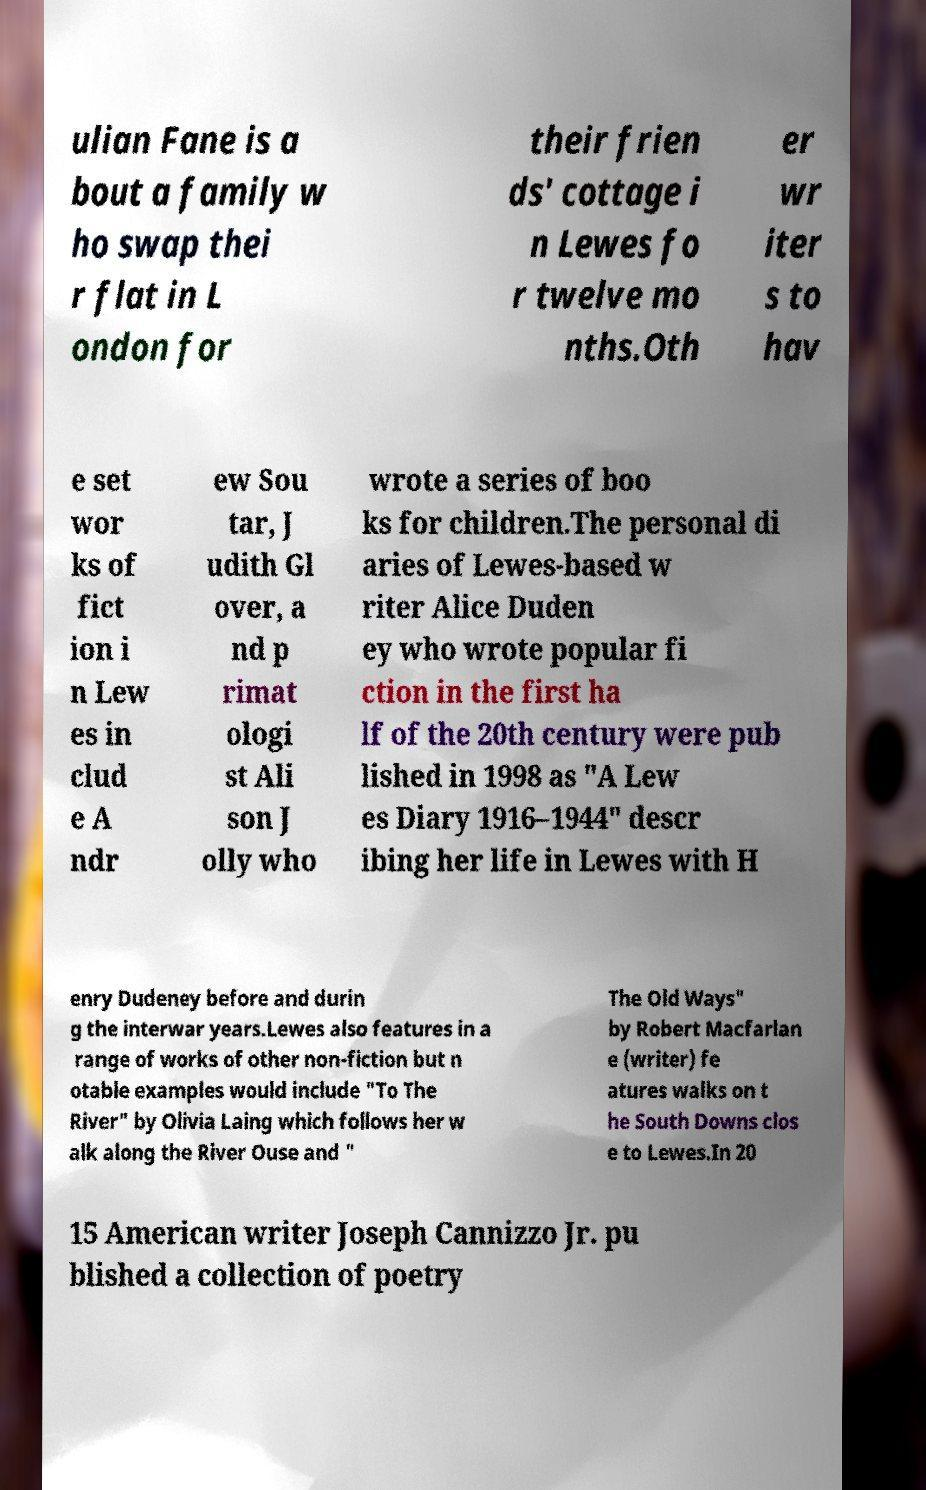I need the written content from this picture converted into text. Can you do that? ulian Fane is a bout a family w ho swap thei r flat in L ondon for their frien ds' cottage i n Lewes fo r twelve mo nths.Oth er wr iter s to hav e set wor ks of fict ion i n Lew es in clud e A ndr ew Sou tar, J udith Gl over, a nd p rimat ologi st Ali son J olly who wrote a series of boo ks for children.The personal di aries of Lewes-based w riter Alice Duden ey who wrote popular fi ction in the first ha lf of the 20th century were pub lished in 1998 as "A Lew es Diary 1916–1944" descr ibing her life in Lewes with H enry Dudeney before and durin g the interwar years.Lewes also features in a range of works of other non-fiction but n otable examples would include "To The River" by Olivia Laing which follows her w alk along the River Ouse and " The Old Ways" by Robert Macfarlan e (writer) fe atures walks on t he South Downs clos e to Lewes.In 20 15 American writer Joseph Cannizzo Jr. pu blished a collection of poetry 